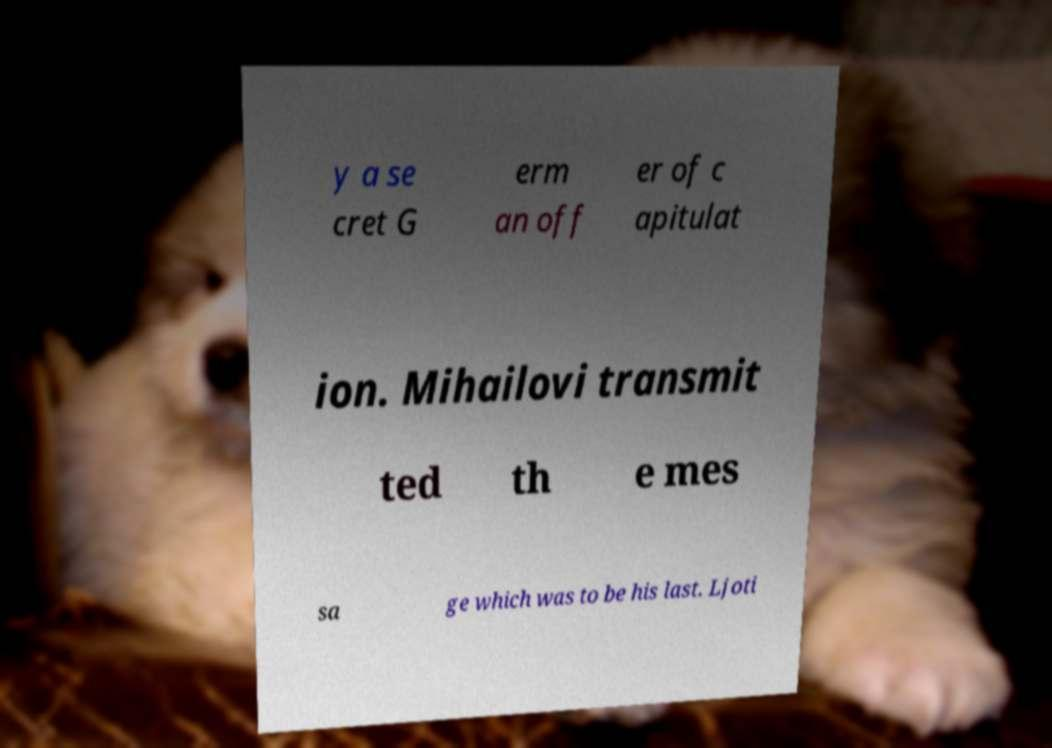Could you assist in decoding the text presented in this image and type it out clearly? y a se cret G erm an off er of c apitulat ion. Mihailovi transmit ted th e mes sa ge which was to be his last. Ljoti 